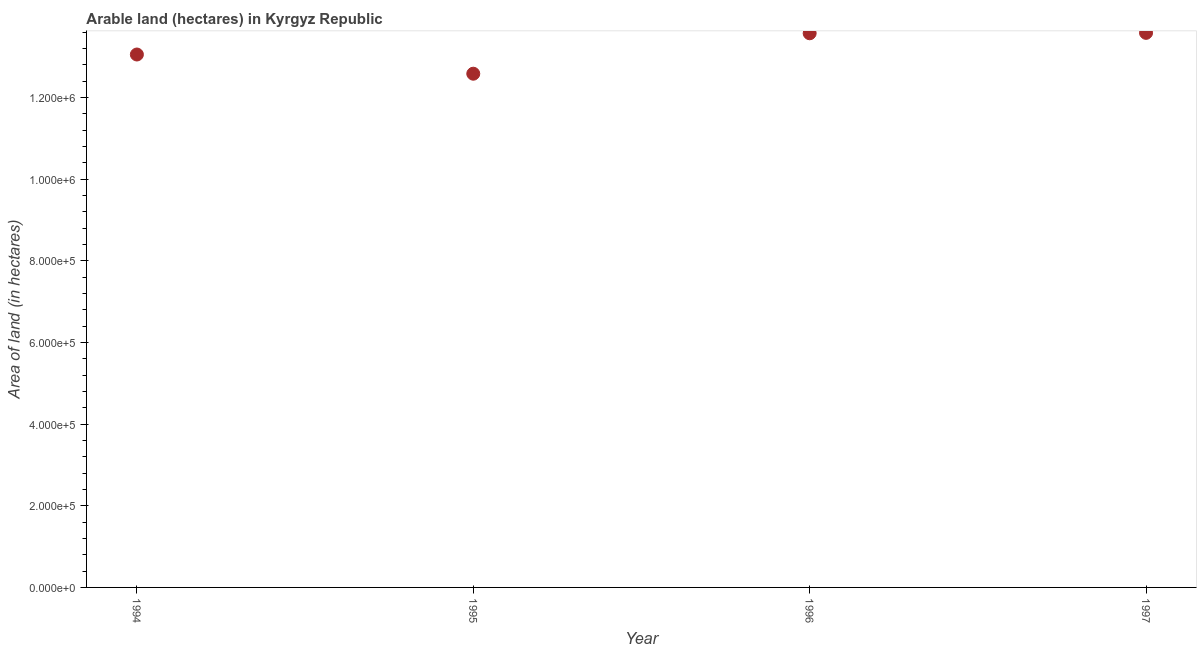What is the area of land in 1994?
Give a very brief answer. 1.30e+06. Across all years, what is the maximum area of land?
Provide a succinct answer. 1.36e+06. Across all years, what is the minimum area of land?
Keep it short and to the point. 1.26e+06. What is the sum of the area of land?
Your answer should be compact. 5.28e+06. What is the difference between the area of land in 1996 and 1997?
Your answer should be compact. -1000. What is the average area of land per year?
Give a very brief answer. 1.32e+06. What is the median area of land?
Make the answer very short. 1.33e+06. In how many years, is the area of land greater than 640000 hectares?
Provide a succinct answer. 4. What is the ratio of the area of land in 1995 to that in 1996?
Offer a terse response. 0.93. Is the area of land in 1995 less than that in 1997?
Give a very brief answer. Yes. Is the difference between the area of land in 1994 and 1996 greater than the difference between any two years?
Ensure brevity in your answer.  No. What is the difference between the highest and the lowest area of land?
Make the answer very short. 1.00e+05. In how many years, is the area of land greater than the average area of land taken over all years?
Your answer should be very brief. 2. Does the graph contain any zero values?
Make the answer very short. No. Does the graph contain grids?
Offer a very short reply. No. What is the title of the graph?
Offer a very short reply. Arable land (hectares) in Kyrgyz Republic. What is the label or title of the Y-axis?
Give a very brief answer. Area of land (in hectares). What is the Area of land (in hectares) in 1994?
Offer a very short reply. 1.30e+06. What is the Area of land (in hectares) in 1995?
Ensure brevity in your answer.  1.26e+06. What is the Area of land (in hectares) in 1996?
Offer a very short reply. 1.36e+06. What is the Area of land (in hectares) in 1997?
Your answer should be very brief. 1.36e+06. What is the difference between the Area of land (in hectares) in 1994 and 1995?
Keep it short and to the point. 4.70e+04. What is the difference between the Area of land (in hectares) in 1994 and 1996?
Offer a very short reply. -5.20e+04. What is the difference between the Area of land (in hectares) in 1994 and 1997?
Make the answer very short. -5.30e+04. What is the difference between the Area of land (in hectares) in 1995 and 1996?
Provide a succinct answer. -9.90e+04. What is the difference between the Area of land (in hectares) in 1995 and 1997?
Offer a terse response. -1.00e+05. What is the difference between the Area of land (in hectares) in 1996 and 1997?
Provide a succinct answer. -1000. What is the ratio of the Area of land (in hectares) in 1994 to that in 1995?
Ensure brevity in your answer.  1.04. What is the ratio of the Area of land (in hectares) in 1994 to that in 1997?
Offer a terse response. 0.96. What is the ratio of the Area of land (in hectares) in 1995 to that in 1996?
Provide a succinct answer. 0.93. What is the ratio of the Area of land (in hectares) in 1995 to that in 1997?
Provide a succinct answer. 0.93. 